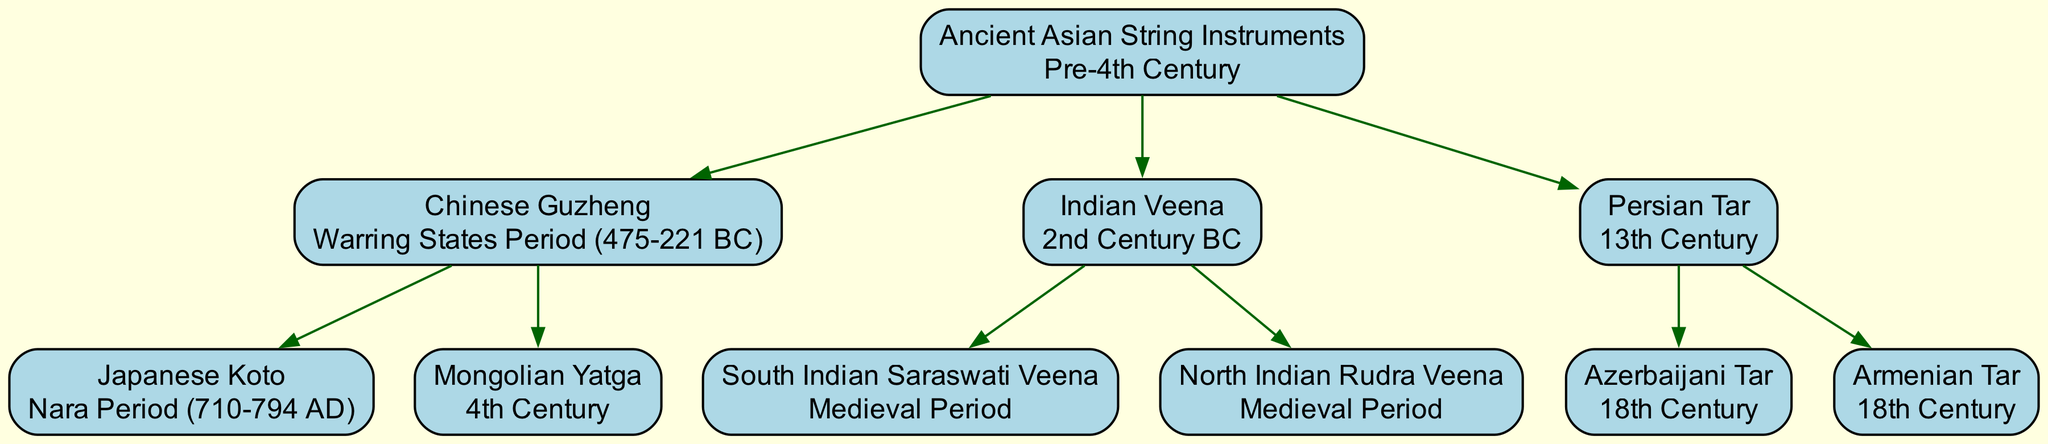What is the root of the family tree? The root node represents the earliest form of the lineage, which is "Ancient Asian String Instruments." It is the starting point from which all descendant instruments derive.
Answer: Ancient Asian String Instruments How many descendants does the Indian Veena have? The Indian Veena has two descendants listed in the diagram: the South Indian Saraswati Veena and the North Indian Rudra Veena. Counting these gives us a total of 2 descendants.
Answer: 2 What period does the Chinese Guzheng originate from? The diagram identifies the origin period of the Chinese Guzheng as the Warring States Period, specifically from 475-221 BC. This information is directly stated in its node.
Answer: Warring States Period (475-221 BC) Which instrument is a descendant of both the Chinese Guzheng and the Indian Veena? By examining the structure, neither the Chinese Guzheng nor the Indian Veena share any direct descendants. Therefore, the answer is that there are no common descendants between them, as they branch out separately from the root.
Answer: None What is the origin period of the Armenian Tar? The Armenian Tar is represented in the diagram with an origin period of the 18th Century, specifically shown in its node description.
Answer: 18th Century How many total instruments are shown in the diagram? By counting the nodes in the diagram, we can identify one root instrument (Ancient Asian String Instruments), three primary instruments (Chinese Guzheng, Indian Veena, Persian Tar), and five total descendants. This leads to a total of 9 instruments altogether.
Answer: 9 Which instrument has the same origin period as the Azerbaijani Tar? Both the Azerbaijani Tar and the Armenian Tar are noted to have originated in the 18th Century. The question checks for similarity in their origin period, confirmed through the descendants of the Persian Tar.
Answer: 18th Century What are the two types of the Indian Veena? The Indian Veena has two distinct types as shown in the diagram: South Indian Saraswati Veena and North Indian Rudra Veena. This is explicitly detailed in the node of the Indian Veena, listing both descendants.
Answer: South Indian Saraswati Veena and North Indian Rudra Veena 